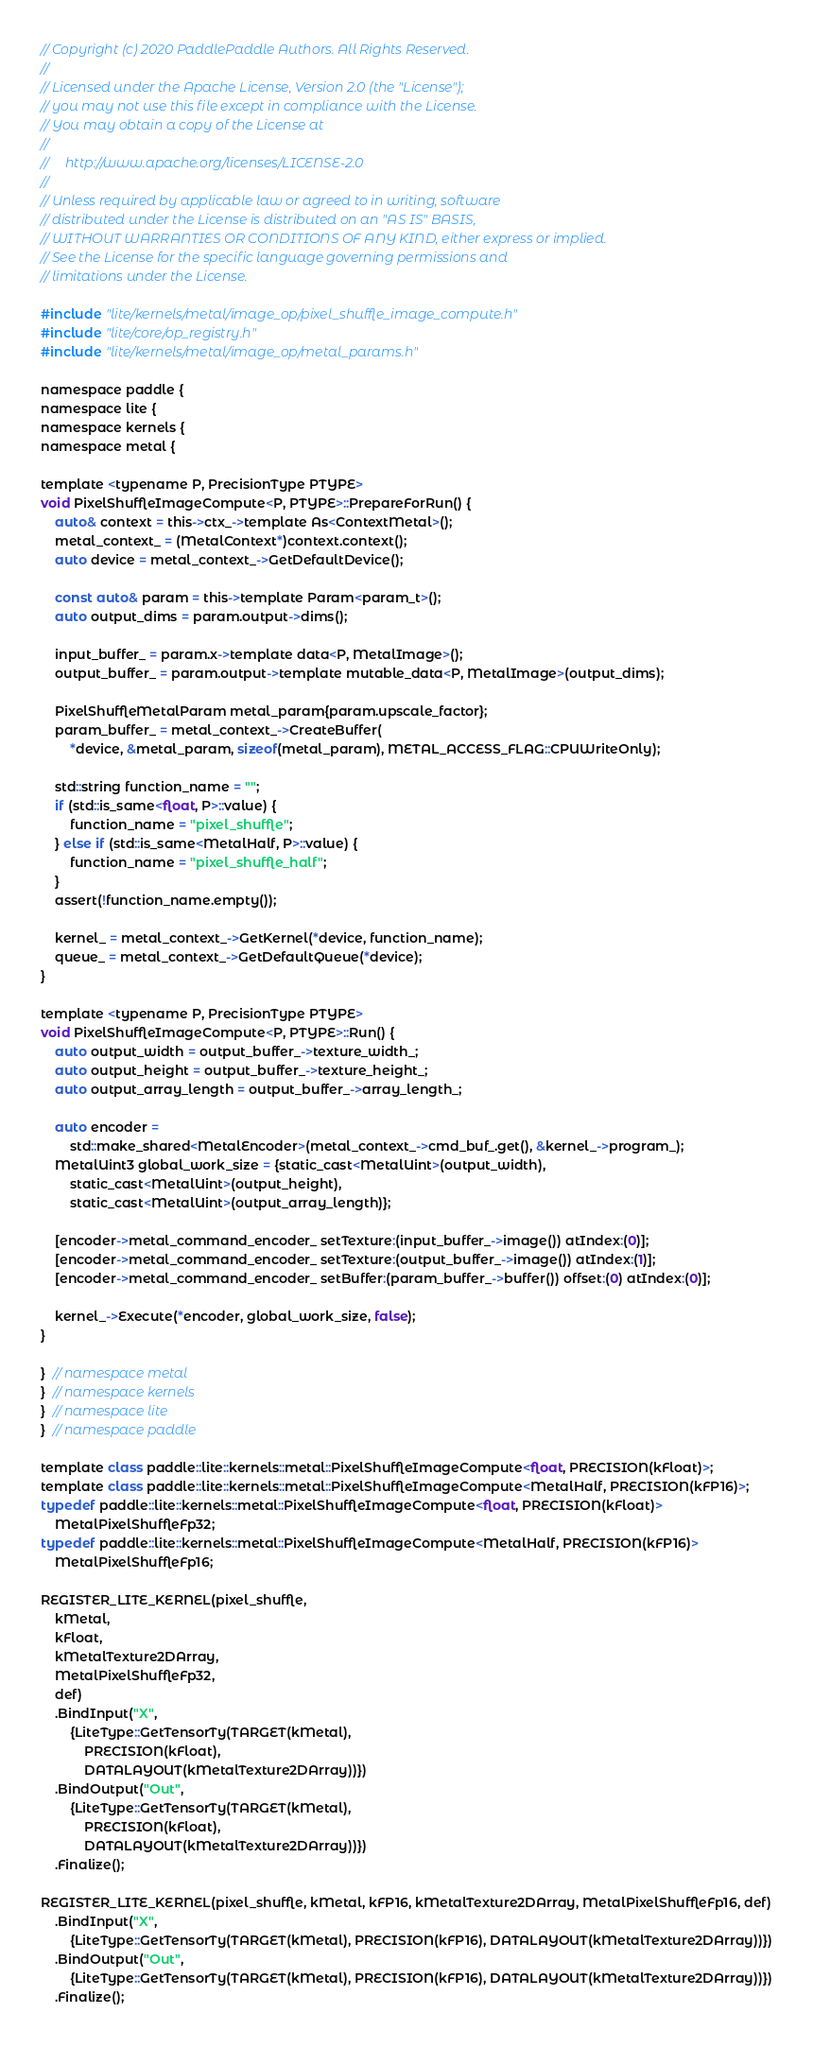<code> <loc_0><loc_0><loc_500><loc_500><_ObjectiveC_>// Copyright (c) 2020 PaddlePaddle Authors. All Rights Reserved.
//
// Licensed under the Apache License, Version 2.0 (the "License");
// you may not use this file except in compliance with the License.
// You may obtain a copy of the License at
//
//     http://www.apache.org/licenses/LICENSE-2.0
//
// Unless required by applicable law or agreed to in writing, software
// distributed under the License is distributed on an "AS IS" BASIS,
// WITHOUT WARRANTIES OR CONDITIONS OF ANY KIND, either express or implied.
// See the License for the specific language governing permissions and
// limitations under the License.

#include "lite/kernels/metal/image_op/pixel_shuffle_image_compute.h"
#include "lite/core/op_registry.h"
#include "lite/kernels/metal/image_op/metal_params.h"

namespace paddle {
namespace lite {
namespace kernels {
namespace metal {

template <typename P, PrecisionType PTYPE>
void PixelShuffleImageCompute<P, PTYPE>::PrepareForRun() {
    auto& context = this->ctx_->template As<ContextMetal>();
    metal_context_ = (MetalContext*)context.context();
    auto device = metal_context_->GetDefaultDevice();

    const auto& param = this->template Param<param_t>();
    auto output_dims = param.output->dims();

    input_buffer_ = param.x->template data<P, MetalImage>();
    output_buffer_ = param.output->template mutable_data<P, MetalImage>(output_dims);

    PixelShuffleMetalParam metal_param{param.upscale_factor};
    param_buffer_ = metal_context_->CreateBuffer(
        *device, &metal_param, sizeof(metal_param), METAL_ACCESS_FLAG::CPUWriteOnly);

    std::string function_name = "";
    if (std::is_same<float, P>::value) {
        function_name = "pixel_shuffle";
    } else if (std::is_same<MetalHalf, P>::value) {
        function_name = "pixel_shuffle_half";
    }
    assert(!function_name.empty());

    kernel_ = metal_context_->GetKernel(*device, function_name);
    queue_ = metal_context_->GetDefaultQueue(*device);
}

template <typename P, PrecisionType PTYPE>
void PixelShuffleImageCompute<P, PTYPE>::Run() {
    auto output_width = output_buffer_->texture_width_;
    auto output_height = output_buffer_->texture_height_;
    auto output_array_length = output_buffer_->array_length_;

    auto encoder =
        std::make_shared<MetalEncoder>(metal_context_->cmd_buf_.get(), &kernel_->program_);
    MetalUint3 global_work_size = {static_cast<MetalUint>(output_width),
        static_cast<MetalUint>(output_height),
        static_cast<MetalUint>(output_array_length)};

    [encoder->metal_command_encoder_ setTexture:(input_buffer_->image()) atIndex:(0)];
    [encoder->metal_command_encoder_ setTexture:(output_buffer_->image()) atIndex:(1)];
    [encoder->metal_command_encoder_ setBuffer:(param_buffer_->buffer()) offset:(0) atIndex:(0)];

    kernel_->Execute(*encoder, global_work_size, false);
}

}  // namespace metal
}  // namespace kernels
}  // namespace lite
}  // namespace paddle

template class paddle::lite::kernels::metal::PixelShuffleImageCompute<float, PRECISION(kFloat)>;
template class paddle::lite::kernels::metal::PixelShuffleImageCompute<MetalHalf, PRECISION(kFP16)>;
typedef paddle::lite::kernels::metal::PixelShuffleImageCompute<float, PRECISION(kFloat)>
    MetalPixelShuffleFp32;
typedef paddle::lite::kernels::metal::PixelShuffleImageCompute<MetalHalf, PRECISION(kFP16)>
    MetalPixelShuffleFp16;

REGISTER_LITE_KERNEL(pixel_shuffle,
    kMetal,
    kFloat,
    kMetalTexture2DArray,
    MetalPixelShuffleFp32,
    def)
    .BindInput("X",
        {LiteType::GetTensorTy(TARGET(kMetal),
            PRECISION(kFloat),
            DATALAYOUT(kMetalTexture2DArray))})
    .BindOutput("Out",
        {LiteType::GetTensorTy(TARGET(kMetal),
            PRECISION(kFloat),
            DATALAYOUT(kMetalTexture2DArray))})
    .Finalize();

REGISTER_LITE_KERNEL(pixel_shuffle, kMetal, kFP16, kMetalTexture2DArray, MetalPixelShuffleFp16, def)
    .BindInput("X",
        {LiteType::GetTensorTy(TARGET(kMetal), PRECISION(kFP16), DATALAYOUT(kMetalTexture2DArray))})
    .BindOutput("Out",
        {LiteType::GetTensorTy(TARGET(kMetal), PRECISION(kFP16), DATALAYOUT(kMetalTexture2DArray))})
    .Finalize();
</code> 